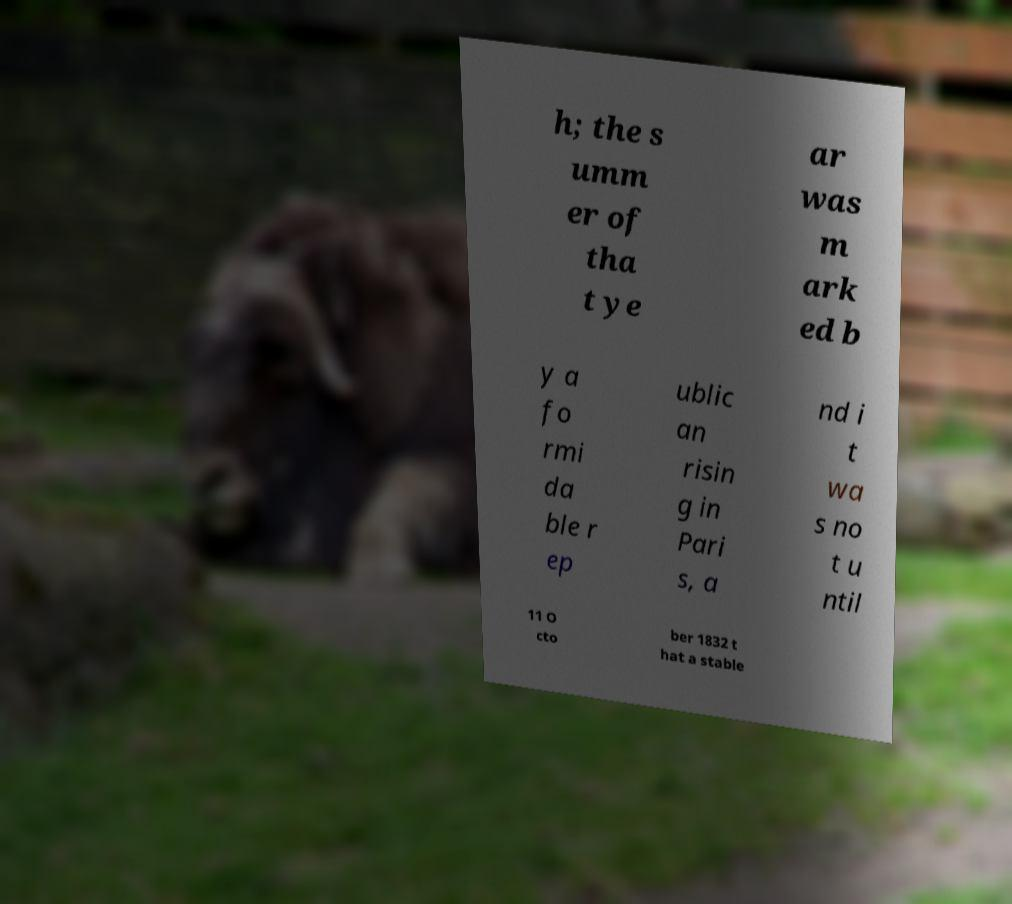I need the written content from this picture converted into text. Can you do that? h; the s umm er of tha t ye ar was m ark ed b y a fo rmi da ble r ep ublic an risin g in Pari s, a nd i t wa s no t u ntil 11 O cto ber 1832 t hat a stable 